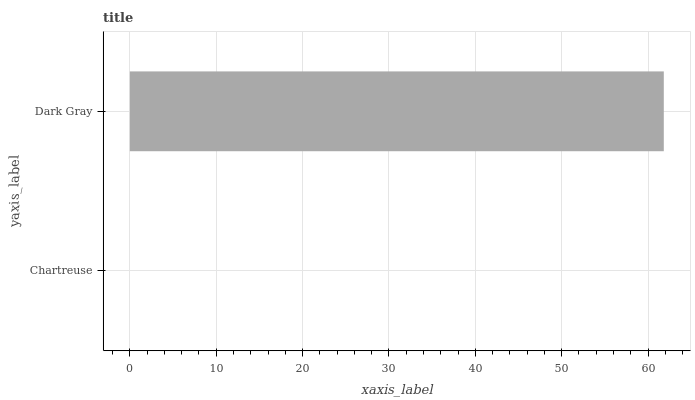Is Chartreuse the minimum?
Answer yes or no. Yes. Is Dark Gray the maximum?
Answer yes or no. Yes. Is Dark Gray the minimum?
Answer yes or no. No. Is Dark Gray greater than Chartreuse?
Answer yes or no. Yes. Is Chartreuse less than Dark Gray?
Answer yes or no. Yes. Is Chartreuse greater than Dark Gray?
Answer yes or no. No. Is Dark Gray less than Chartreuse?
Answer yes or no. No. Is Dark Gray the high median?
Answer yes or no. Yes. Is Chartreuse the low median?
Answer yes or no. Yes. Is Chartreuse the high median?
Answer yes or no. No. Is Dark Gray the low median?
Answer yes or no. No. 